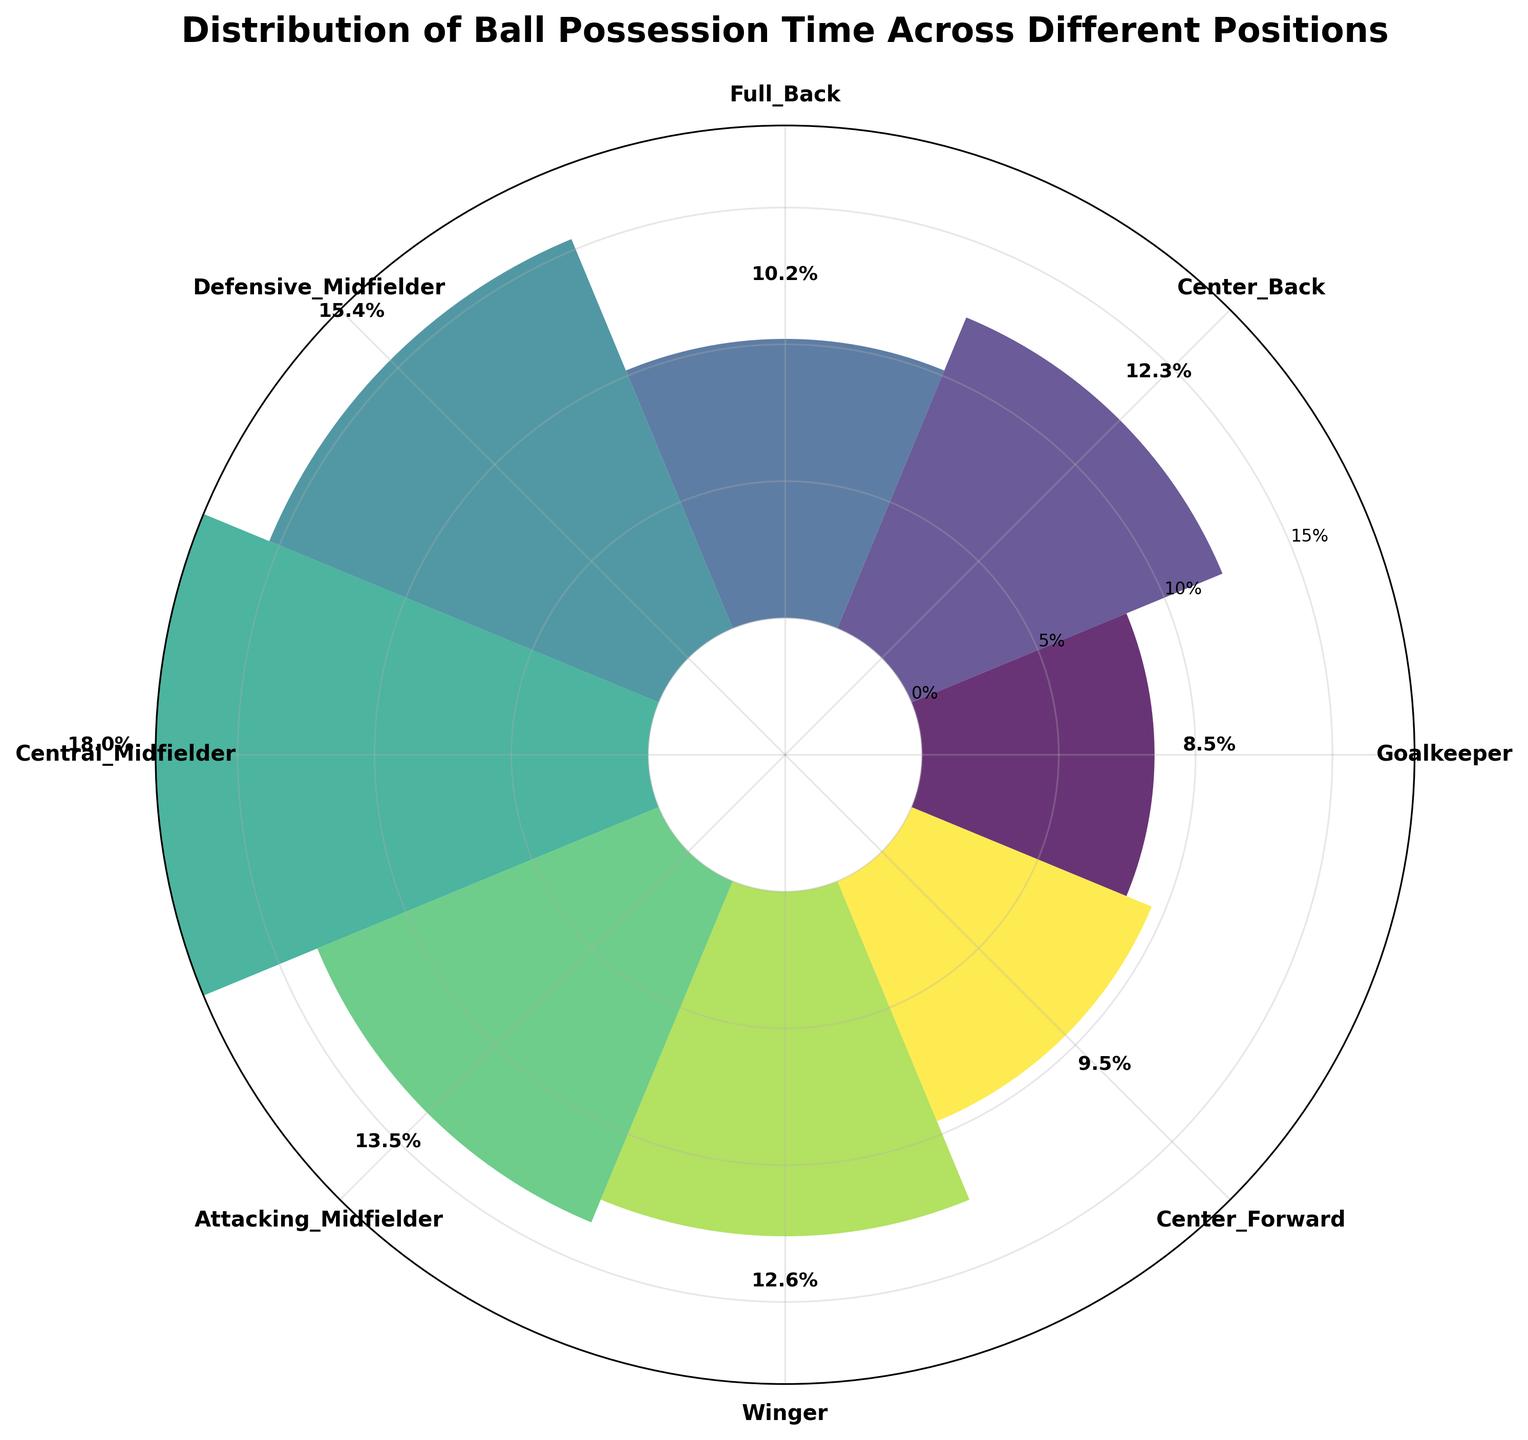Which position has the highest ball possession time percentage? The title indicates the chart shows ball possession time percentages by position. The highest bar corresponds to the position with the highest percentage. The Central Midfielder has the highest with 18.0%.
Answer: Central Midfielder What's the total ball possession time percentage for all midfield positions combined? The midfield positions are Defensive Midfielder, Central Midfielder, and Attacking Midfielder. Their percentages are 15.4%, 18.0%, and 13.5%, respectively. Summing these gives 15.4 + 18.0 + 13.5 = 46.9%.
Answer: 46.9% Which position has the lowest ball possession time percentage? The smallest bar corresponds to the position with the lowest percentage. The Goalkeeper has the lowest with 8.5%.
Answer: Goalkeeper How many positions have a ball possession time percentage higher than 10%? By examining each bar, the positions with >10% are Center Back (12.3%), Full Back (10.2%), Defensive Midfielder (15.4%), Central Midfielder (18.0%), Attacking Midfielder (13.5%), and Winger (12.6%). There are 6 such positions.
Answer: 6 Compare the ball possession time between Winger and Center Forward. The bar for Winger shows 12.6%, and the bar for Center Forward shows 9.5%. Winger has a higher possession time.
Answer: Winger Which positions are closest in ball possession time percentage? By comparing the bars, the closest values are Center Back (12.3%) and Winger (12.6%), with a small difference of 0.3%.
Answer: Center Back and Winger What is the average ball possession time percentage across all positions? Sum all percentages and divide by the number of positions. The sum is 8.5 + 12.3 + 10.2 + 15.4 + 18.0 + 13.5 + 12.6 + 9.5 = 100.0%. The number of positions is 8. So, the average is 100.0 / 8 = 12.5%.
Answer: 12.5% Does any position have equal or less ball possession than the Center Forward? The Center Forward has 9.5%. The Goalkeeper has 8.5%, which is less.
Answer: Goalkeeper 